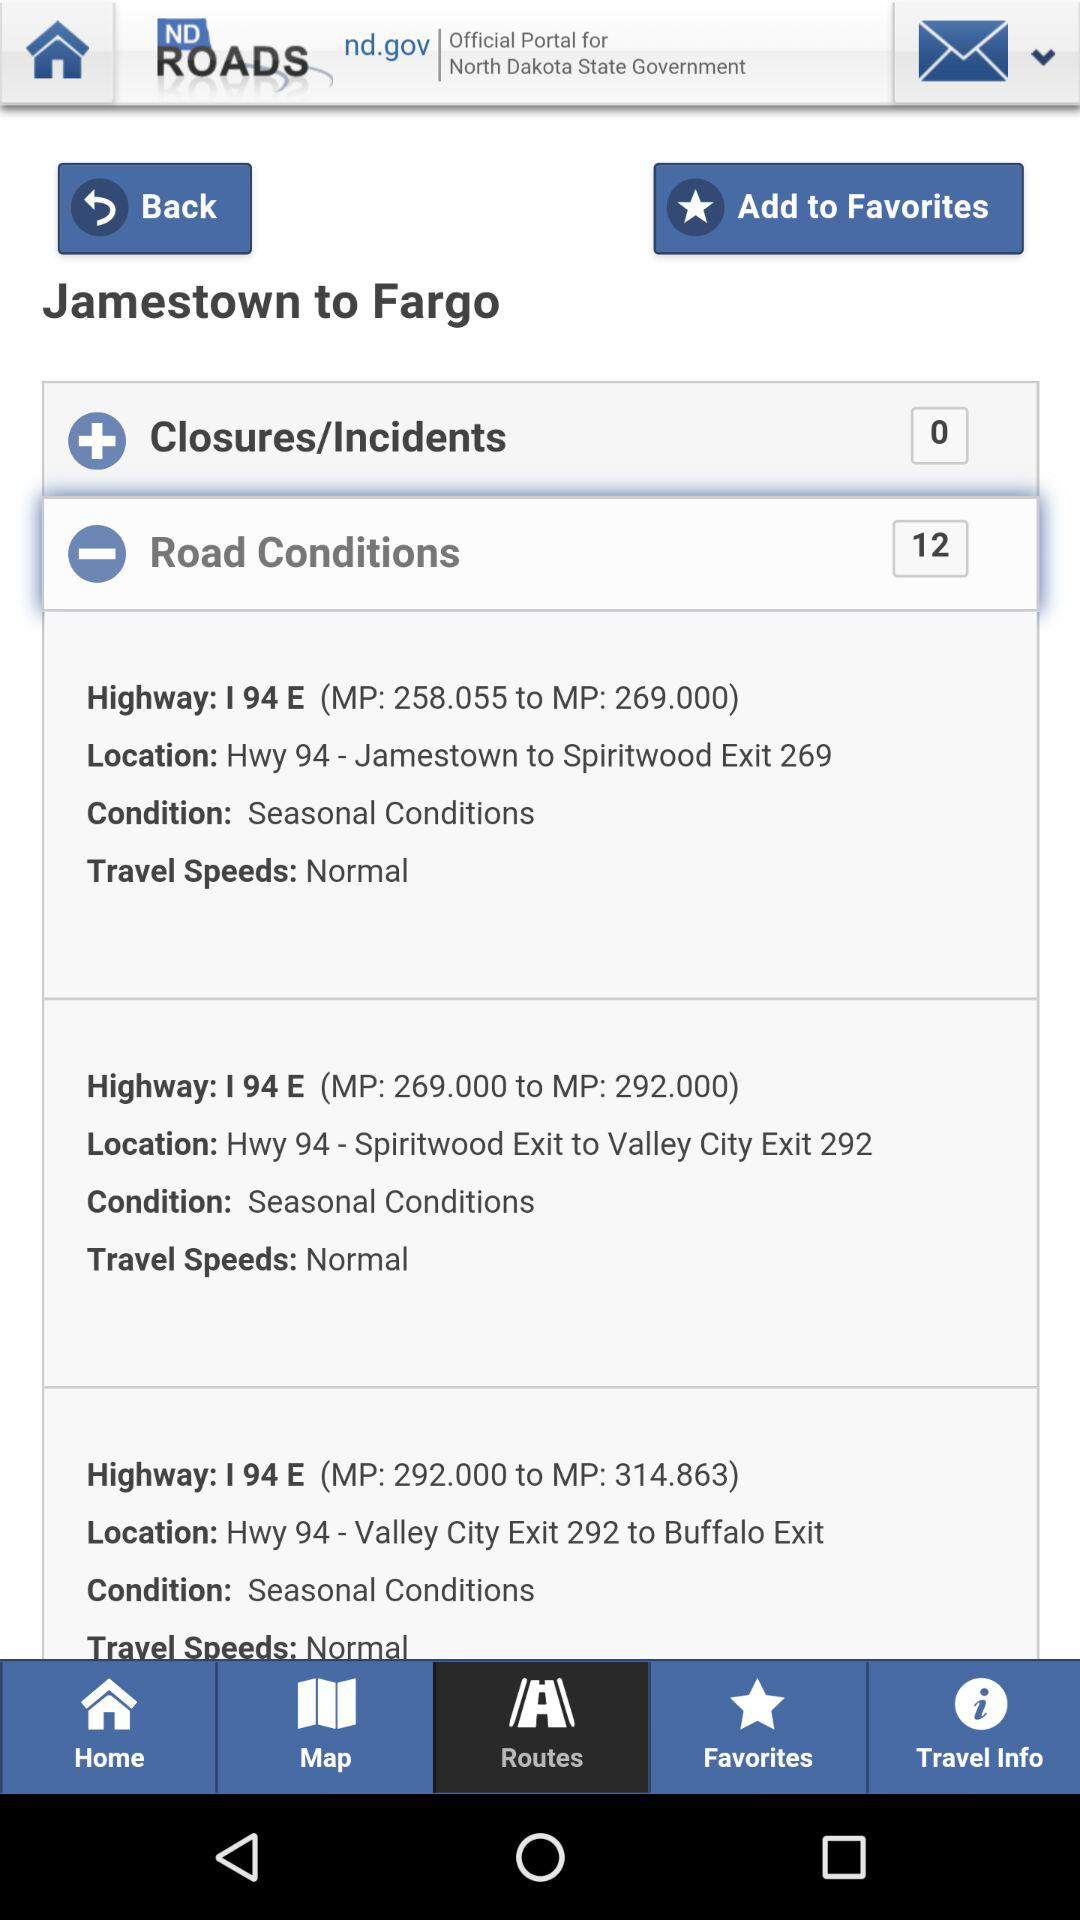What should be the travel speed on the highway "I 94 E (MP: 258.055 to MP: 269.000)"? The travel speed should be "Normal". 